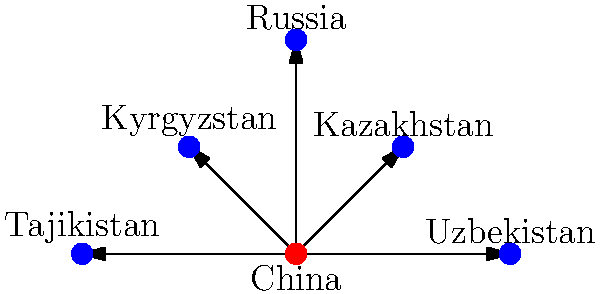Based on the network diagram illustrating China's Belt and Road Initiative (BRI) in Eurasia, which country appears to be the most central node in this network, and how might this affect the balance of power in the region according to Alexander Cooley's perspective on great power competition? To answer this question, let's analyze the diagram and apply concepts from Alexander Cooley's work on great power competition in Eurasia:

1. Network structure: The diagram shows China at the center, directly connected to five Eurasian countries (Kazakhstan, Kyrgyzstan, Russia, Tajikistan, and Uzbekistan).

2. Centrality: China's position as the hub in this network indicates its central role in the BRI, connecting it to multiple Eurasian partners.

3. Cooley's perspective: Alexander Cooley has written extensively about how external powers, particularly China and Russia, compete for influence in Central Asia and how this affects regional politics.

4. BRI impact: The Belt and Road Initiative, as shown in the diagram, potentially increases China's influence across Eurasia by creating economic and infrastructure links.

5. Balance of power: According to Cooley's work, this increased Chinese presence through the BRI could:
   a) Challenge Russia's traditional dominance in the region
   b) Create new dependencies for Central Asian states on Chinese investment and trade
   c) Potentially lead to a reconfiguration of regional alliances and partnerships

6. Implications: The network structure suggests that China could leverage its central position to:
   a) Coordinate regional policies
   b) Influence bilateral relationships between other countries in the network
   c) Potentially mediate disputes or conflicts among its partners

7. Cooley's analysis: He would likely argue that this network structure reflects China's growing ability to shape Eurasian politics and economics, potentially at the expense of other powers like Russia or the United States.

In conclusion, China's central position in this BRI network diagram aligns with Cooley's observations about shifting power dynamics in Eurasia, with China gaining increased influence through economic and infrastructure projects.
Answer: China; increased regional influence and potential power shift in Eurasia 